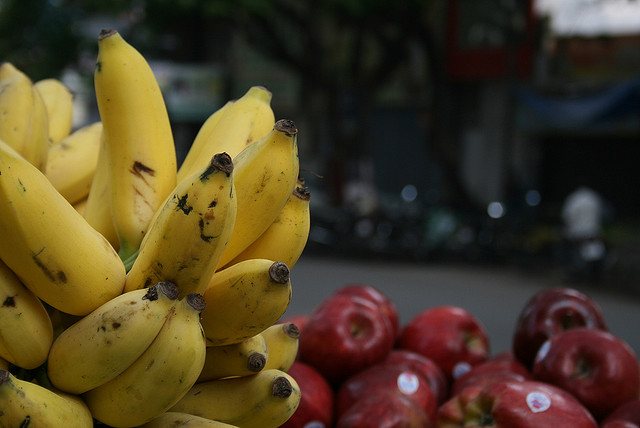<image>What purple fruit is shown? I am not sure. No fruit could be seen. What purple fruit is shown? I am not sure which purple fruit is shown. It can be either an apple or there might be no purple fruit in the image. 